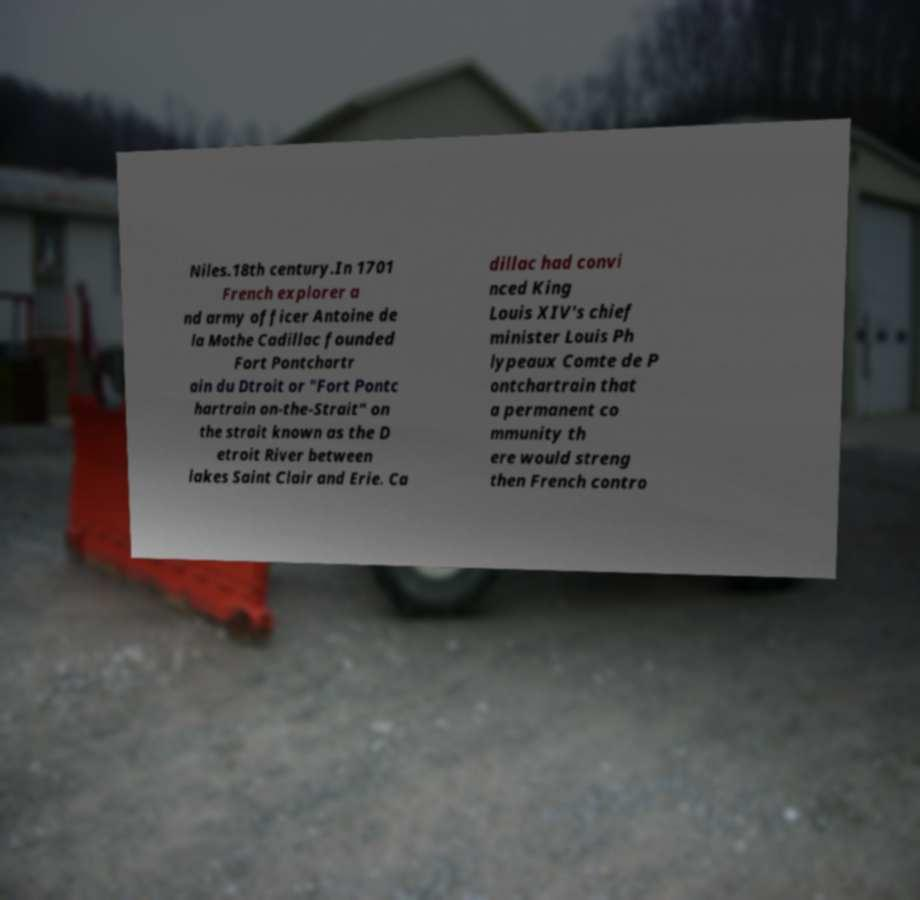Can you accurately transcribe the text from the provided image for me? Niles.18th century.In 1701 French explorer a nd army officer Antoine de la Mothe Cadillac founded Fort Pontchartr ain du Dtroit or "Fort Pontc hartrain on-the-Strait" on the strait known as the D etroit River between lakes Saint Clair and Erie. Ca dillac had convi nced King Louis XIV's chief minister Louis Ph lypeaux Comte de P ontchartrain that a permanent co mmunity th ere would streng then French contro 